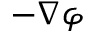Convert formula to latex. <formula><loc_0><loc_0><loc_500><loc_500>- \nabla \varphi</formula> 